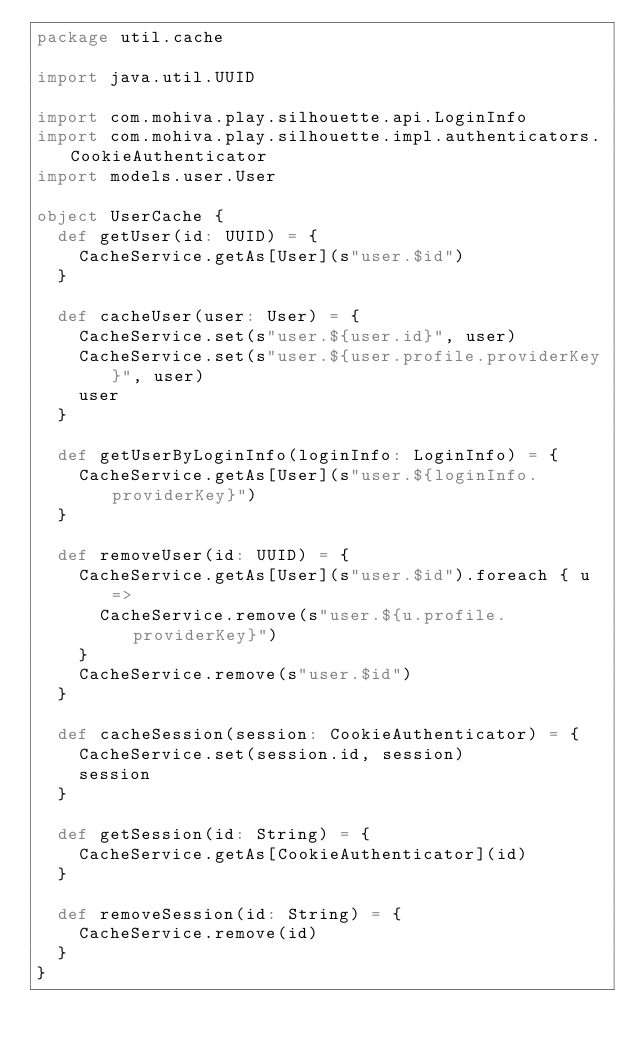<code> <loc_0><loc_0><loc_500><loc_500><_Scala_>package util.cache

import java.util.UUID

import com.mohiva.play.silhouette.api.LoginInfo
import com.mohiva.play.silhouette.impl.authenticators.CookieAuthenticator
import models.user.User

object UserCache {
  def getUser(id: UUID) = {
    CacheService.getAs[User](s"user.$id")
  }

  def cacheUser(user: User) = {
    CacheService.set(s"user.${user.id}", user)
    CacheService.set(s"user.${user.profile.providerKey}", user)
    user
  }

  def getUserByLoginInfo(loginInfo: LoginInfo) = {
    CacheService.getAs[User](s"user.${loginInfo.providerKey}")
  }

  def removeUser(id: UUID) = {
    CacheService.getAs[User](s"user.$id").foreach { u =>
      CacheService.remove(s"user.${u.profile.providerKey}")
    }
    CacheService.remove(s"user.$id")
  }

  def cacheSession(session: CookieAuthenticator) = {
    CacheService.set(session.id, session)
    session
  }

  def getSession(id: String) = {
    CacheService.getAs[CookieAuthenticator](id)
  }

  def removeSession(id: String) = {
    CacheService.remove(id)
  }
}
</code> 